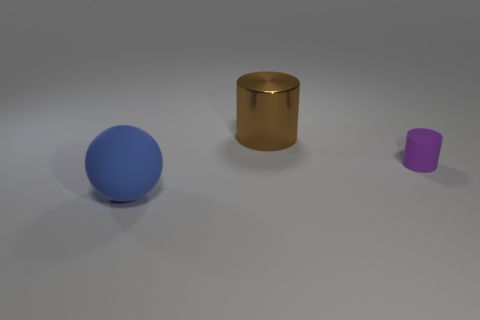Subtract all purple cylinders. How many cylinders are left? 1 Subtract all blue spheres. How many red cylinders are left? 0 Add 2 brown things. How many objects exist? 5 Subtract all balls. How many objects are left? 2 Subtract all green cylinders. Subtract all yellow blocks. How many cylinders are left? 2 Subtract all large metal spheres. Subtract all purple things. How many objects are left? 2 Add 2 purple rubber cylinders. How many purple rubber cylinders are left? 3 Add 1 green metal objects. How many green metal objects exist? 1 Subtract 0 green blocks. How many objects are left? 3 Subtract 2 cylinders. How many cylinders are left? 0 